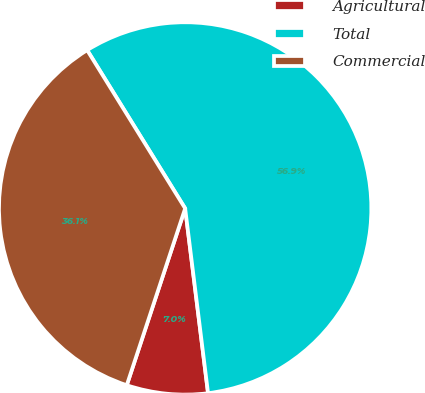Convert chart. <chart><loc_0><loc_0><loc_500><loc_500><pie_chart><fcel>Agricultural<fcel>Total<fcel>Commercial<nl><fcel>7.04%<fcel>56.86%<fcel>36.1%<nl></chart> 